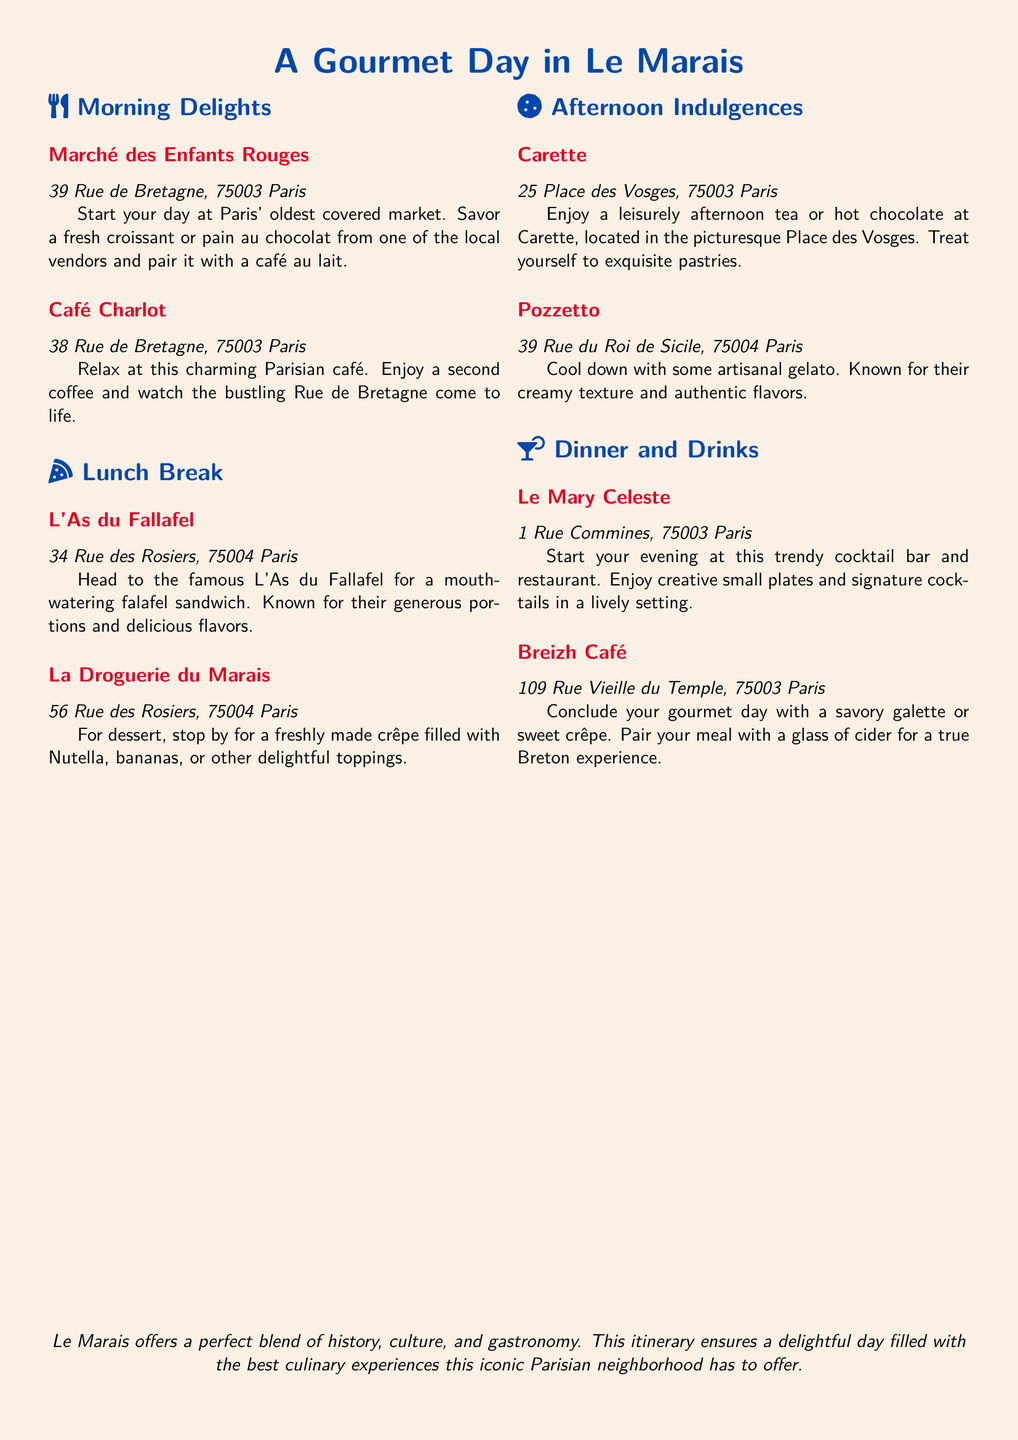What is the name of the oldest covered market in Paris? The document mentions "Marché des Enfants Rouges" as Paris' oldest covered market.
Answer: Marché des Enfants Rouges Where can you get a falafel sandwich in Le Marais? The document specifies "L'As du Fallafel" for a mouth-watering falafel sandwich.
Answer: L'As du Fallafel What dessert can you find at La Droguerie du Marais? The document states that La Droguerie du Marais offers freshly made crêpes filled with various toppings.
Answer: Crêpe What is the address of Café Charlot? The document lists the address of Café Charlot as "38 Rue de Bretagne, 75003 Paris".
Answer: 38 Rue de Bretagne, 75003 Paris Which café is located in Place des Vosges? The document mentions "Carette" as the café located in the picturesque Place des Vosges.
Answer: Carette How many meal stops are in this itinerary? The document includes six meal stops: two for morning delights, one for lunch, two for afternoon indulgences, and one for dinner.
Answer: Six What type of establishment is Le Mary Celeste? The document describes Le Mary Celeste as a trendy cocktail bar and restaurant.
Answer: Cocktail bar and restaurant What is a unique feature of Pozzetto's offerings? The document highlights Pozzetto for its artisanal gelato known for creamy texture and authentic flavors.
Answer: Artisanal gelato What drink is suggested to pair with a meal at Breizh Café? According to the document, a glass of cider is suggested to be paired with a meal.
Answer: Cider 